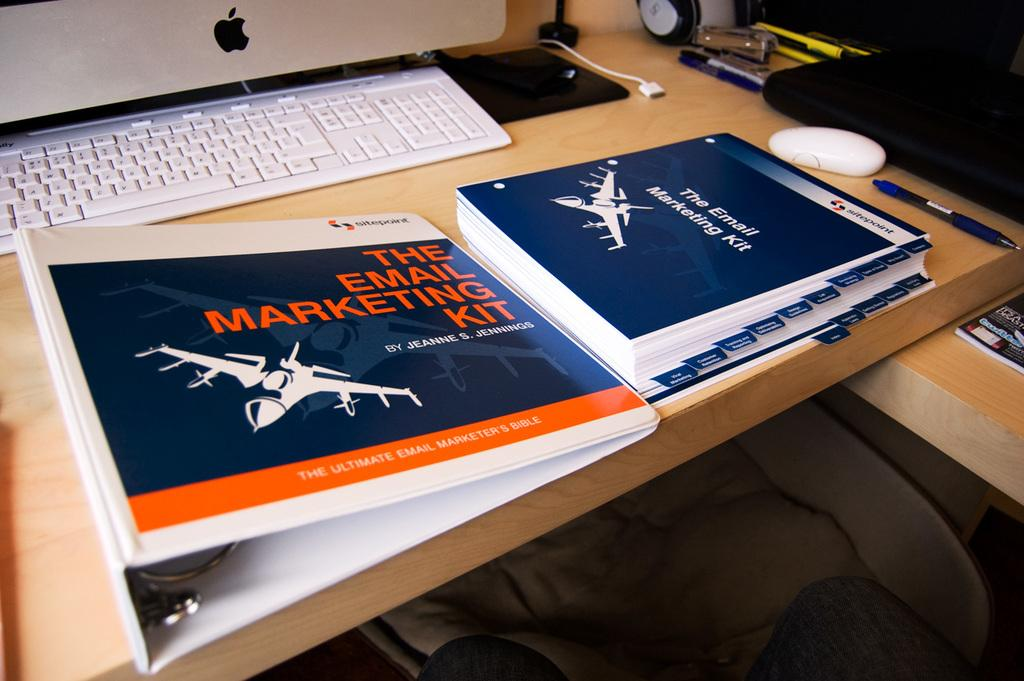<image>
Describe the image concisely. A folder on a desk labeled "the email marketing kit - the ultimate email marketing bible." 